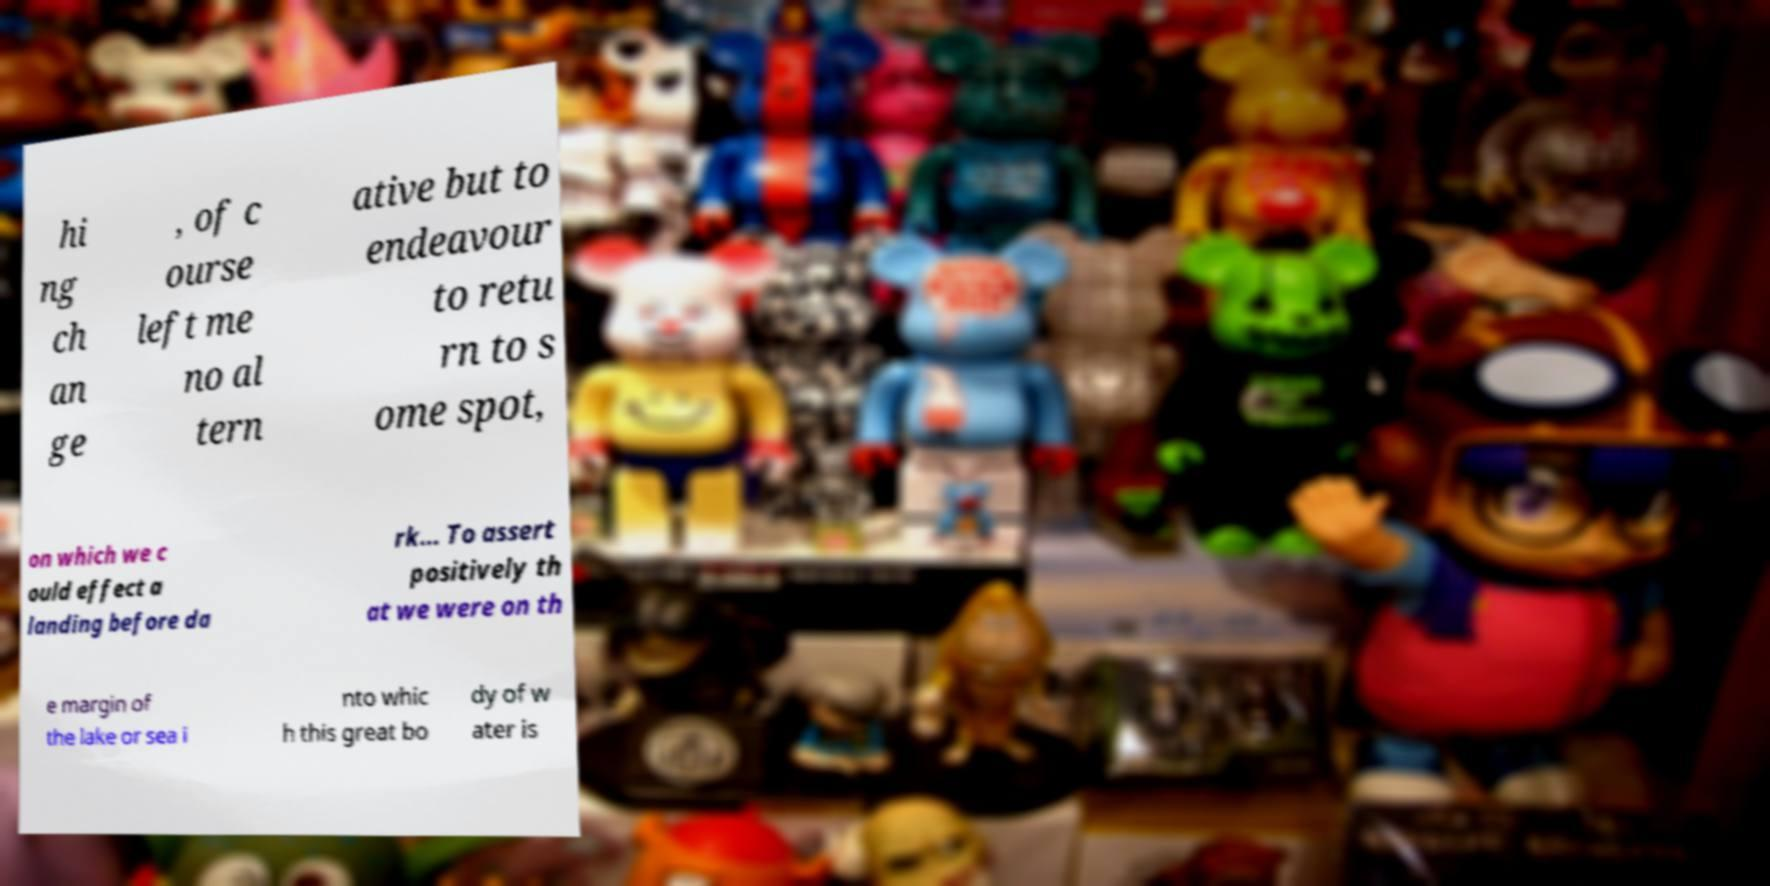There's text embedded in this image that I need extracted. Can you transcribe it verbatim? hi ng ch an ge , of c ourse left me no al tern ative but to endeavour to retu rn to s ome spot, on which we c ould effect a landing before da rk... To assert positively th at we were on th e margin of the lake or sea i nto whic h this great bo dy of w ater is 